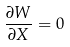Convert formula to latex. <formula><loc_0><loc_0><loc_500><loc_500>\frac { \partial W } { \partial X } = 0</formula> 